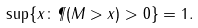Convert formula to latex. <formula><loc_0><loc_0><loc_500><loc_500>\sup \{ x \colon \P ( M > x ) > 0 \} = 1 .</formula> 